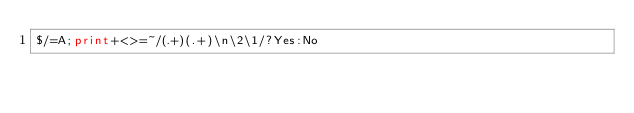Convert code to text. <code><loc_0><loc_0><loc_500><loc_500><_Perl_>$/=A;print+<>=~/(.+)(.+)\n\2\1/?Yes:No</code> 